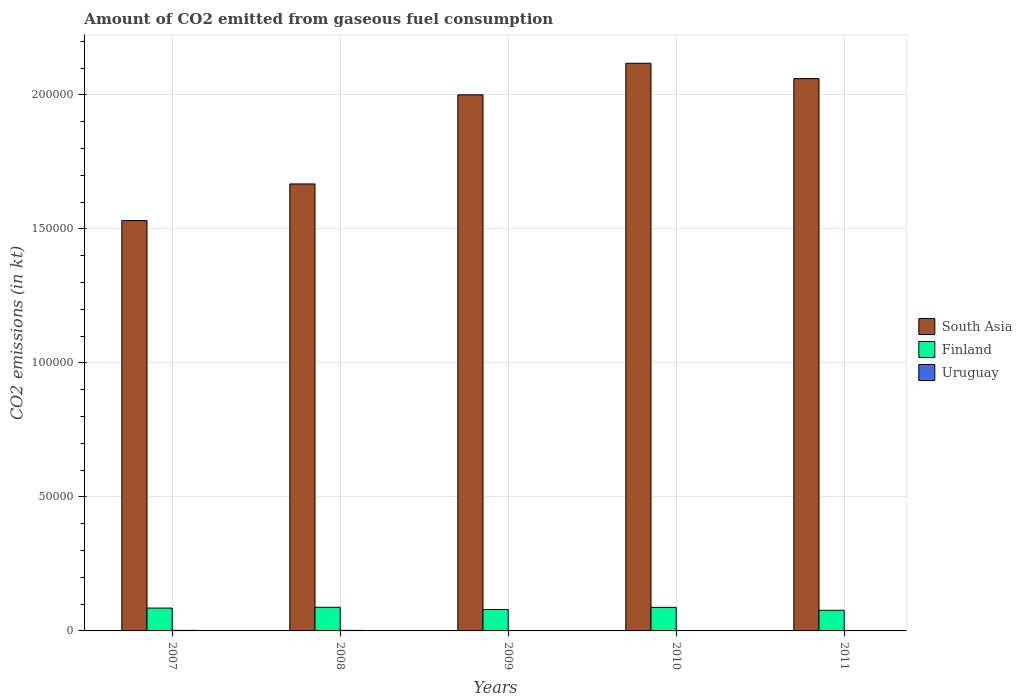How many different coloured bars are there?
Make the answer very short. 3. How many bars are there on the 3rd tick from the right?
Make the answer very short. 3. What is the amount of CO2 emitted in Finland in 2007?
Ensure brevity in your answer.  8525.77. Across all years, what is the maximum amount of CO2 emitted in Uruguay?
Provide a succinct answer. 194.35. Across all years, what is the minimum amount of CO2 emitted in Uruguay?
Make the answer very short. 132.01. What is the total amount of CO2 emitted in South Asia in the graph?
Your answer should be compact. 9.38e+05. What is the difference between the amount of CO2 emitted in Finland in 2009 and that in 2010?
Ensure brevity in your answer.  -810.41. What is the difference between the amount of CO2 emitted in Uruguay in 2011 and the amount of CO2 emitted in South Asia in 2010?
Provide a short and direct response. -2.12e+05. What is the average amount of CO2 emitted in South Asia per year?
Make the answer very short. 1.88e+05. In the year 2009, what is the difference between the amount of CO2 emitted in South Asia and amount of CO2 emitted in Finland?
Provide a succinct answer. 1.92e+05. In how many years, is the amount of CO2 emitted in Uruguay greater than 200000 kt?
Your answer should be very brief. 0. What is the ratio of the amount of CO2 emitted in Uruguay in 2008 to that in 2009?
Your answer should be very brief. 1.44. Is the amount of CO2 emitted in South Asia in 2007 less than that in 2010?
Offer a very short reply. Yes. Is the difference between the amount of CO2 emitted in South Asia in 2008 and 2010 greater than the difference between the amount of CO2 emitted in Finland in 2008 and 2010?
Provide a short and direct response. No. What is the difference between the highest and the second highest amount of CO2 emitted in Finland?
Provide a succinct answer. 33. What is the difference between the highest and the lowest amount of CO2 emitted in South Asia?
Make the answer very short. 5.87e+04. What does the 2nd bar from the right in 2008 represents?
Provide a succinct answer. Finland. Is it the case that in every year, the sum of the amount of CO2 emitted in South Asia and amount of CO2 emitted in Uruguay is greater than the amount of CO2 emitted in Finland?
Provide a succinct answer. Yes. How many bars are there?
Make the answer very short. 15. How many years are there in the graph?
Provide a succinct answer. 5. What is the difference between two consecutive major ticks on the Y-axis?
Your response must be concise. 5.00e+04. Are the values on the major ticks of Y-axis written in scientific E-notation?
Your answer should be compact. No. Does the graph contain grids?
Your answer should be compact. Yes. Where does the legend appear in the graph?
Keep it short and to the point. Center right. What is the title of the graph?
Offer a very short reply. Amount of CO2 emitted from gaseous fuel consumption. What is the label or title of the Y-axis?
Offer a terse response. CO2 emissions (in kt). What is the CO2 emissions (in kt) of South Asia in 2007?
Offer a terse response. 1.53e+05. What is the CO2 emissions (in kt) of Finland in 2007?
Provide a short and direct response. 8525.77. What is the CO2 emissions (in kt) of Uruguay in 2007?
Your response must be concise. 194.35. What is the CO2 emissions (in kt) in South Asia in 2008?
Your answer should be compact. 1.67e+05. What is the CO2 emissions (in kt) of Finland in 2008?
Offer a terse response. 8822.8. What is the CO2 emissions (in kt) in Uruguay in 2008?
Keep it short and to the point. 190.68. What is the CO2 emissions (in kt) in South Asia in 2009?
Keep it short and to the point. 2.00e+05. What is the CO2 emissions (in kt) of Finland in 2009?
Your answer should be very brief. 7979.39. What is the CO2 emissions (in kt) in Uruguay in 2009?
Provide a succinct answer. 132.01. What is the CO2 emissions (in kt) in South Asia in 2010?
Ensure brevity in your answer.  2.12e+05. What is the CO2 emissions (in kt) in Finland in 2010?
Ensure brevity in your answer.  8789.8. What is the CO2 emissions (in kt) in Uruguay in 2010?
Your response must be concise. 132.01. What is the CO2 emissions (in kt) in South Asia in 2011?
Your response must be concise. 2.06e+05. What is the CO2 emissions (in kt) in Finland in 2011?
Offer a terse response. 7697.03. What is the CO2 emissions (in kt) of Uruguay in 2011?
Ensure brevity in your answer.  146.68. Across all years, what is the maximum CO2 emissions (in kt) in South Asia?
Offer a very short reply. 2.12e+05. Across all years, what is the maximum CO2 emissions (in kt) of Finland?
Offer a terse response. 8822.8. Across all years, what is the maximum CO2 emissions (in kt) in Uruguay?
Your answer should be very brief. 194.35. Across all years, what is the minimum CO2 emissions (in kt) of South Asia?
Make the answer very short. 1.53e+05. Across all years, what is the minimum CO2 emissions (in kt) in Finland?
Provide a succinct answer. 7697.03. Across all years, what is the minimum CO2 emissions (in kt) of Uruguay?
Offer a terse response. 132.01. What is the total CO2 emissions (in kt) in South Asia in the graph?
Give a very brief answer. 9.38e+05. What is the total CO2 emissions (in kt) of Finland in the graph?
Keep it short and to the point. 4.18e+04. What is the total CO2 emissions (in kt) of Uruguay in the graph?
Your answer should be very brief. 795.74. What is the difference between the CO2 emissions (in kt) in South Asia in 2007 and that in 2008?
Your response must be concise. -1.37e+04. What is the difference between the CO2 emissions (in kt) in Finland in 2007 and that in 2008?
Give a very brief answer. -297.03. What is the difference between the CO2 emissions (in kt) of Uruguay in 2007 and that in 2008?
Keep it short and to the point. 3.67. What is the difference between the CO2 emissions (in kt) in South Asia in 2007 and that in 2009?
Provide a short and direct response. -4.69e+04. What is the difference between the CO2 emissions (in kt) in Finland in 2007 and that in 2009?
Make the answer very short. 546.38. What is the difference between the CO2 emissions (in kt) of Uruguay in 2007 and that in 2009?
Offer a very short reply. 62.34. What is the difference between the CO2 emissions (in kt) in South Asia in 2007 and that in 2010?
Your response must be concise. -5.87e+04. What is the difference between the CO2 emissions (in kt) of Finland in 2007 and that in 2010?
Make the answer very short. -264.02. What is the difference between the CO2 emissions (in kt) in Uruguay in 2007 and that in 2010?
Ensure brevity in your answer.  62.34. What is the difference between the CO2 emissions (in kt) in South Asia in 2007 and that in 2011?
Your answer should be compact. -5.30e+04. What is the difference between the CO2 emissions (in kt) in Finland in 2007 and that in 2011?
Your answer should be very brief. 828.74. What is the difference between the CO2 emissions (in kt) of Uruguay in 2007 and that in 2011?
Offer a very short reply. 47.67. What is the difference between the CO2 emissions (in kt) in South Asia in 2008 and that in 2009?
Keep it short and to the point. -3.33e+04. What is the difference between the CO2 emissions (in kt) of Finland in 2008 and that in 2009?
Offer a very short reply. 843.41. What is the difference between the CO2 emissions (in kt) in Uruguay in 2008 and that in 2009?
Provide a succinct answer. 58.67. What is the difference between the CO2 emissions (in kt) of South Asia in 2008 and that in 2010?
Provide a short and direct response. -4.50e+04. What is the difference between the CO2 emissions (in kt) of Finland in 2008 and that in 2010?
Keep it short and to the point. 33. What is the difference between the CO2 emissions (in kt) in Uruguay in 2008 and that in 2010?
Ensure brevity in your answer.  58.67. What is the difference between the CO2 emissions (in kt) in South Asia in 2008 and that in 2011?
Your response must be concise. -3.93e+04. What is the difference between the CO2 emissions (in kt) of Finland in 2008 and that in 2011?
Offer a terse response. 1125.77. What is the difference between the CO2 emissions (in kt) of Uruguay in 2008 and that in 2011?
Ensure brevity in your answer.  44. What is the difference between the CO2 emissions (in kt) in South Asia in 2009 and that in 2010?
Your response must be concise. -1.18e+04. What is the difference between the CO2 emissions (in kt) in Finland in 2009 and that in 2010?
Your response must be concise. -810.41. What is the difference between the CO2 emissions (in kt) in Uruguay in 2009 and that in 2010?
Ensure brevity in your answer.  0. What is the difference between the CO2 emissions (in kt) of South Asia in 2009 and that in 2011?
Your answer should be very brief. -6053.1. What is the difference between the CO2 emissions (in kt) of Finland in 2009 and that in 2011?
Provide a short and direct response. 282.36. What is the difference between the CO2 emissions (in kt) of Uruguay in 2009 and that in 2011?
Provide a short and direct response. -14.67. What is the difference between the CO2 emissions (in kt) in South Asia in 2010 and that in 2011?
Your response must be concise. 5723.55. What is the difference between the CO2 emissions (in kt) in Finland in 2010 and that in 2011?
Keep it short and to the point. 1092.77. What is the difference between the CO2 emissions (in kt) in Uruguay in 2010 and that in 2011?
Your answer should be compact. -14.67. What is the difference between the CO2 emissions (in kt) of South Asia in 2007 and the CO2 emissions (in kt) of Finland in 2008?
Your answer should be very brief. 1.44e+05. What is the difference between the CO2 emissions (in kt) in South Asia in 2007 and the CO2 emissions (in kt) in Uruguay in 2008?
Keep it short and to the point. 1.53e+05. What is the difference between the CO2 emissions (in kt) of Finland in 2007 and the CO2 emissions (in kt) of Uruguay in 2008?
Keep it short and to the point. 8335.09. What is the difference between the CO2 emissions (in kt) in South Asia in 2007 and the CO2 emissions (in kt) in Finland in 2009?
Give a very brief answer. 1.45e+05. What is the difference between the CO2 emissions (in kt) of South Asia in 2007 and the CO2 emissions (in kt) of Uruguay in 2009?
Your response must be concise. 1.53e+05. What is the difference between the CO2 emissions (in kt) of Finland in 2007 and the CO2 emissions (in kt) of Uruguay in 2009?
Provide a succinct answer. 8393.76. What is the difference between the CO2 emissions (in kt) in South Asia in 2007 and the CO2 emissions (in kt) in Finland in 2010?
Make the answer very short. 1.44e+05. What is the difference between the CO2 emissions (in kt) in South Asia in 2007 and the CO2 emissions (in kt) in Uruguay in 2010?
Your response must be concise. 1.53e+05. What is the difference between the CO2 emissions (in kt) in Finland in 2007 and the CO2 emissions (in kt) in Uruguay in 2010?
Your answer should be compact. 8393.76. What is the difference between the CO2 emissions (in kt) in South Asia in 2007 and the CO2 emissions (in kt) in Finland in 2011?
Provide a short and direct response. 1.45e+05. What is the difference between the CO2 emissions (in kt) of South Asia in 2007 and the CO2 emissions (in kt) of Uruguay in 2011?
Your response must be concise. 1.53e+05. What is the difference between the CO2 emissions (in kt) of Finland in 2007 and the CO2 emissions (in kt) of Uruguay in 2011?
Keep it short and to the point. 8379.09. What is the difference between the CO2 emissions (in kt) in South Asia in 2008 and the CO2 emissions (in kt) in Finland in 2009?
Your answer should be very brief. 1.59e+05. What is the difference between the CO2 emissions (in kt) of South Asia in 2008 and the CO2 emissions (in kt) of Uruguay in 2009?
Your answer should be very brief. 1.67e+05. What is the difference between the CO2 emissions (in kt) of Finland in 2008 and the CO2 emissions (in kt) of Uruguay in 2009?
Provide a short and direct response. 8690.79. What is the difference between the CO2 emissions (in kt) in South Asia in 2008 and the CO2 emissions (in kt) in Finland in 2010?
Offer a terse response. 1.58e+05. What is the difference between the CO2 emissions (in kt) in South Asia in 2008 and the CO2 emissions (in kt) in Uruguay in 2010?
Your answer should be very brief. 1.67e+05. What is the difference between the CO2 emissions (in kt) of Finland in 2008 and the CO2 emissions (in kt) of Uruguay in 2010?
Ensure brevity in your answer.  8690.79. What is the difference between the CO2 emissions (in kt) in South Asia in 2008 and the CO2 emissions (in kt) in Finland in 2011?
Make the answer very short. 1.59e+05. What is the difference between the CO2 emissions (in kt) of South Asia in 2008 and the CO2 emissions (in kt) of Uruguay in 2011?
Your answer should be very brief. 1.67e+05. What is the difference between the CO2 emissions (in kt) in Finland in 2008 and the CO2 emissions (in kt) in Uruguay in 2011?
Provide a succinct answer. 8676.12. What is the difference between the CO2 emissions (in kt) in South Asia in 2009 and the CO2 emissions (in kt) in Finland in 2010?
Your response must be concise. 1.91e+05. What is the difference between the CO2 emissions (in kt) in South Asia in 2009 and the CO2 emissions (in kt) in Uruguay in 2010?
Offer a terse response. 2.00e+05. What is the difference between the CO2 emissions (in kt) in Finland in 2009 and the CO2 emissions (in kt) in Uruguay in 2010?
Your answer should be compact. 7847.38. What is the difference between the CO2 emissions (in kt) in South Asia in 2009 and the CO2 emissions (in kt) in Finland in 2011?
Make the answer very short. 1.92e+05. What is the difference between the CO2 emissions (in kt) of South Asia in 2009 and the CO2 emissions (in kt) of Uruguay in 2011?
Ensure brevity in your answer.  2.00e+05. What is the difference between the CO2 emissions (in kt) of Finland in 2009 and the CO2 emissions (in kt) of Uruguay in 2011?
Ensure brevity in your answer.  7832.71. What is the difference between the CO2 emissions (in kt) of South Asia in 2010 and the CO2 emissions (in kt) of Finland in 2011?
Keep it short and to the point. 2.04e+05. What is the difference between the CO2 emissions (in kt) in South Asia in 2010 and the CO2 emissions (in kt) in Uruguay in 2011?
Keep it short and to the point. 2.12e+05. What is the difference between the CO2 emissions (in kt) in Finland in 2010 and the CO2 emissions (in kt) in Uruguay in 2011?
Your answer should be compact. 8643.12. What is the average CO2 emissions (in kt) of South Asia per year?
Give a very brief answer. 1.88e+05. What is the average CO2 emissions (in kt) of Finland per year?
Ensure brevity in your answer.  8362.96. What is the average CO2 emissions (in kt) in Uruguay per year?
Keep it short and to the point. 159.15. In the year 2007, what is the difference between the CO2 emissions (in kt) of South Asia and CO2 emissions (in kt) of Finland?
Give a very brief answer. 1.45e+05. In the year 2007, what is the difference between the CO2 emissions (in kt) in South Asia and CO2 emissions (in kt) in Uruguay?
Ensure brevity in your answer.  1.53e+05. In the year 2007, what is the difference between the CO2 emissions (in kt) in Finland and CO2 emissions (in kt) in Uruguay?
Offer a terse response. 8331.42. In the year 2008, what is the difference between the CO2 emissions (in kt) in South Asia and CO2 emissions (in kt) in Finland?
Offer a terse response. 1.58e+05. In the year 2008, what is the difference between the CO2 emissions (in kt) of South Asia and CO2 emissions (in kt) of Uruguay?
Your answer should be very brief. 1.67e+05. In the year 2008, what is the difference between the CO2 emissions (in kt) of Finland and CO2 emissions (in kt) of Uruguay?
Give a very brief answer. 8632.12. In the year 2009, what is the difference between the CO2 emissions (in kt) in South Asia and CO2 emissions (in kt) in Finland?
Ensure brevity in your answer.  1.92e+05. In the year 2009, what is the difference between the CO2 emissions (in kt) in South Asia and CO2 emissions (in kt) in Uruguay?
Give a very brief answer. 2.00e+05. In the year 2009, what is the difference between the CO2 emissions (in kt) in Finland and CO2 emissions (in kt) in Uruguay?
Your answer should be very brief. 7847.38. In the year 2010, what is the difference between the CO2 emissions (in kt) of South Asia and CO2 emissions (in kt) of Finland?
Offer a very short reply. 2.03e+05. In the year 2010, what is the difference between the CO2 emissions (in kt) of South Asia and CO2 emissions (in kt) of Uruguay?
Provide a succinct answer. 2.12e+05. In the year 2010, what is the difference between the CO2 emissions (in kt) in Finland and CO2 emissions (in kt) in Uruguay?
Offer a terse response. 8657.79. In the year 2011, what is the difference between the CO2 emissions (in kt) of South Asia and CO2 emissions (in kt) of Finland?
Make the answer very short. 1.98e+05. In the year 2011, what is the difference between the CO2 emissions (in kt) in South Asia and CO2 emissions (in kt) in Uruguay?
Offer a terse response. 2.06e+05. In the year 2011, what is the difference between the CO2 emissions (in kt) in Finland and CO2 emissions (in kt) in Uruguay?
Make the answer very short. 7550.35. What is the ratio of the CO2 emissions (in kt) of South Asia in 2007 to that in 2008?
Offer a very short reply. 0.92. What is the ratio of the CO2 emissions (in kt) in Finland in 2007 to that in 2008?
Offer a very short reply. 0.97. What is the ratio of the CO2 emissions (in kt) in Uruguay in 2007 to that in 2008?
Provide a succinct answer. 1.02. What is the ratio of the CO2 emissions (in kt) of South Asia in 2007 to that in 2009?
Ensure brevity in your answer.  0.77. What is the ratio of the CO2 emissions (in kt) in Finland in 2007 to that in 2009?
Give a very brief answer. 1.07. What is the ratio of the CO2 emissions (in kt) of Uruguay in 2007 to that in 2009?
Your answer should be very brief. 1.47. What is the ratio of the CO2 emissions (in kt) in South Asia in 2007 to that in 2010?
Your answer should be compact. 0.72. What is the ratio of the CO2 emissions (in kt) in Uruguay in 2007 to that in 2010?
Your answer should be compact. 1.47. What is the ratio of the CO2 emissions (in kt) in South Asia in 2007 to that in 2011?
Your answer should be very brief. 0.74. What is the ratio of the CO2 emissions (in kt) in Finland in 2007 to that in 2011?
Ensure brevity in your answer.  1.11. What is the ratio of the CO2 emissions (in kt) of Uruguay in 2007 to that in 2011?
Your answer should be very brief. 1.32. What is the ratio of the CO2 emissions (in kt) in South Asia in 2008 to that in 2009?
Your answer should be compact. 0.83. What is the ratio of the CO2 emissions (in kt) in Finland in 2008 to that in 2009?
Give a very brief answer. 1.11. What is the ratio of the CO2 emissions (in kt) in Uruguay in 2008 to that in 2009?
Ensure brevity in your answer.  1.44. What is the ratio of the CO2 emissions (in kt) in South Asia in 2008 to that in 2010?
Provide a succinct answer. 0.79. What is the ratio of the CO2 emissions (in kt) of Finland in 2008 to that in 2010?
Provide a short and direct response. 1. What is the ratio of the CO2 emissions (in kt) in Uruguay in 2008 to that in 2010?
Your answer should be compact. 1.44. What is the ratio of the CO2 emissions (in kt) of South Asia in 2008 to that in 2011?
Provide a short and direct response. 0.81. What is the ratio of the CO2 emissions (in kt) of Finland in 2008 to that in 2011?
Ensure brevity in your answer.  1.15. What is the ratio of the CO2 emissions (in kt) in Uruguay in 2008 to that in 2011?
Your answer should be compact. 1.3. What is the ratio of the CO2 emissions (in kt) of Finland in 2009 to that in 2010?
Provide a succinct answer. 0.91. What is the ratio of the CO2 emissions (in kt) in South Asia in 2009 to that in 2011?
Keep it short and to the point. 0.97. What is the ratio of the CO2 emissions (in kt) in Finland in 2009 to that in 2011?
Ensure brevity in your answer.  1.04. What is the ratio of the CO2 emissions (in kt) of Uruguay in 2009 to that in 2011?
Keep it short and to the point. 0.9. What is the ratio of the CO2 emissions (in kt) in South Asia in 2010 to that in 2011?
Provide a short and direct response. 1.03. What is the ratio of the CO2 emissions (in kt) in Finland in 2010 to that in 2011?
Your response must be concise. 1.14. What is the difference between the highest and the second highest CO2 emissions (in kt) of South Asia?
Provide a succinct answer. 5723.55. What is the difference between the highest and the second highest CO2 emissions (in kt) of Finland?
Provide a succinct answer. 33. What is the difference between the highest and the second highest CO2 emissions (in kt) in Uruguay?
Give a very brief answer. 3.67. What is the difference between the highest and the lowest CO2 emissions (in kt) in South Asia?
Keep it short and to the point. 5.87e+04. What is the difference between the highest and the lowest CO2 emissions (in kt) in Finland?
Your response must be concise. 1125.77. What is the difference between the highest and the lowest CO2 emissions (in kt) of Uruguay?
Your response must be concise. 62.34. 